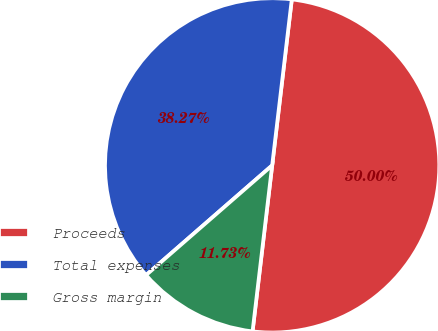<chart> <loc_0><loc_0><loc_500><loc_500><pie_chart><fcel>Proceeds<fcel>Total expenses<fcel>Gross margin<nl><fcel>50.0%<fcel>38.27%<fcel>11.73%<nl></chart> 